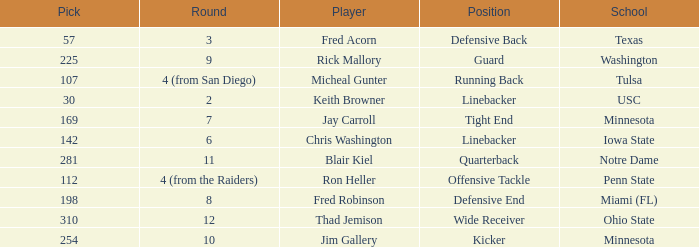Write the full table. {'header': ['Pick', 'Round', 'Player', 'Position', 'School'], 'rows': [['57', '3', 'Fred Acorn', 'Defensive Back', 'Texas'], ['225', '9', 'Rick Mallory', 'Guard', 'Washington'], ['107', '4 (from San Diego)', 'Micheal Gunter', 'Running Back', 'Tulsa'], ['30', '2', 'Keith Browner', 'Linebacker', 'USC'], ['169', '7', 'Jay Carroll', 'Tight End', 'Minnesota'], ['142', '6', 'Chris Washington', 'Linebacker', 'Iowa State'], ['281', '11', 'Blair Kiel', 'Quarterback', 'Notre Dame'], ['112', '4 (from the Raiders)', 'Ron Heller', 'Offensive Tackle', 'Penn State'], ['198', '8', 'Fred Robinson', 'Defensive End', 'Miami (FL)'], ['310', '12', 'Thad Jemison', 'Wide Receiver', 'Ohio State'], ['254', '10', 'Jim Gallery', 'Kicker', 'Minnesota']]} What is the total pick number for a wide receiver? 1.0. 